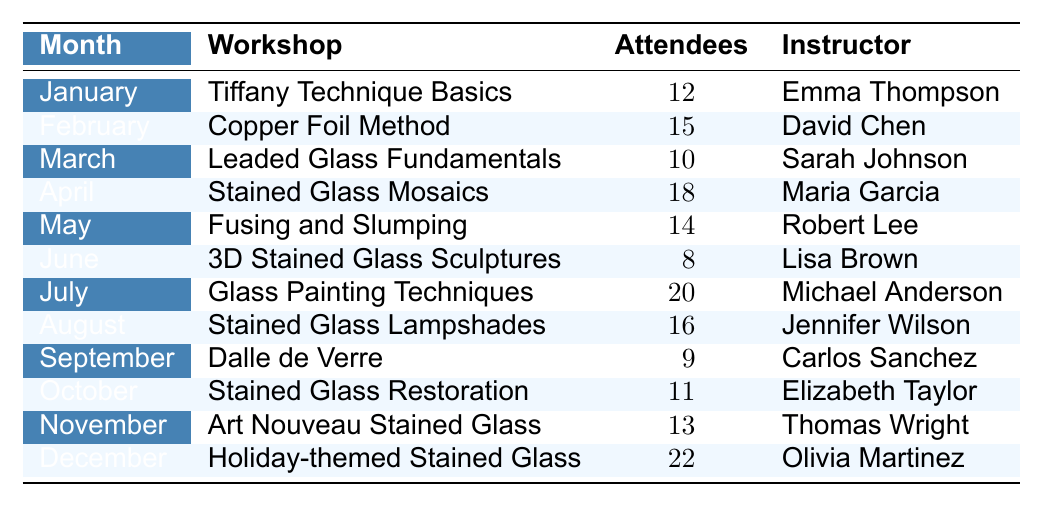What was the total number of attendees in December? According to the table, December had 22 attendees for the Holiday-themed Stained Glass workshop.
Answer: 22 Which workshop had the highest number of attendees? The table shows that the Holiday-themed Stained Glass in December had the highest number of attendees at 22.
Answer: Holiday-themed Stained Glass How many attendees participated in the Tiffany Technique Basics workshop? The data reveals that 12 attendees participated in the Tiffany Technique Basics workshop in January.
Answer: 12 What is the average number of attendees across all months? To find the average, we sum the number of attendees: 12 + 15 + 10 + 18 + 14 + 8 + 20 + 16 + 9 + 11 + 13 + 22 =  16.25 and then divide by 12 months, so the average is 16.25.
Answer: 16.25 Did the Copper Foil Method have more attendees than the Leaded Glass Fundamentals workshop? The Copper Foil Method in February had 15 attendees, while the Leaded Glass Fundamentals in March had 10. Therefore, the Copper Foil Method had more attendees.
Answer: Yes Which month had the least number of attendees and how many were there? The month with the least number of attendees was June, with 8 attendees for the 3D Stained Glass Sculptures workshop.
Answer: June, 8 What is the total attendance for the first half of the year (January to June)? Adding the attendees for these months: 12 (Jan) + 15 (Feb) + 10 (Mar) + 18 (Apr) + 14 (May) + 8 (Jun) = 77. Thus, the total attendance for the first half of the year is 77.
Answer: 77 How many workshops had more than 15 attendees? Looking at the data, the workshops with more than 15 attendees are: Copper Foil Method (15), Stained Glass Mosaics (18), Glass Painting Techniques (20), Stained Glass Lampshades (16), and Holiday-themed Stained Glass (22). Thus, 5 workshops had over 15 attendees.
Answer: 5 Which instructor had the most attendees across their workshops? The Holiday-themed Stained Glass workshop, instructed by Olivia Martinez, had the highest attendance of 22, which is more than the other instructors' maximums.
Answer: Olivia Martinez How does the attendance in July compare to the average attendance of the year? The attendance in July was 20. The average attendance calculated earlier is 16.25, and since 20 is greater than 16.25, it means July had a higher attendance than average.
Answer: Higher than average 